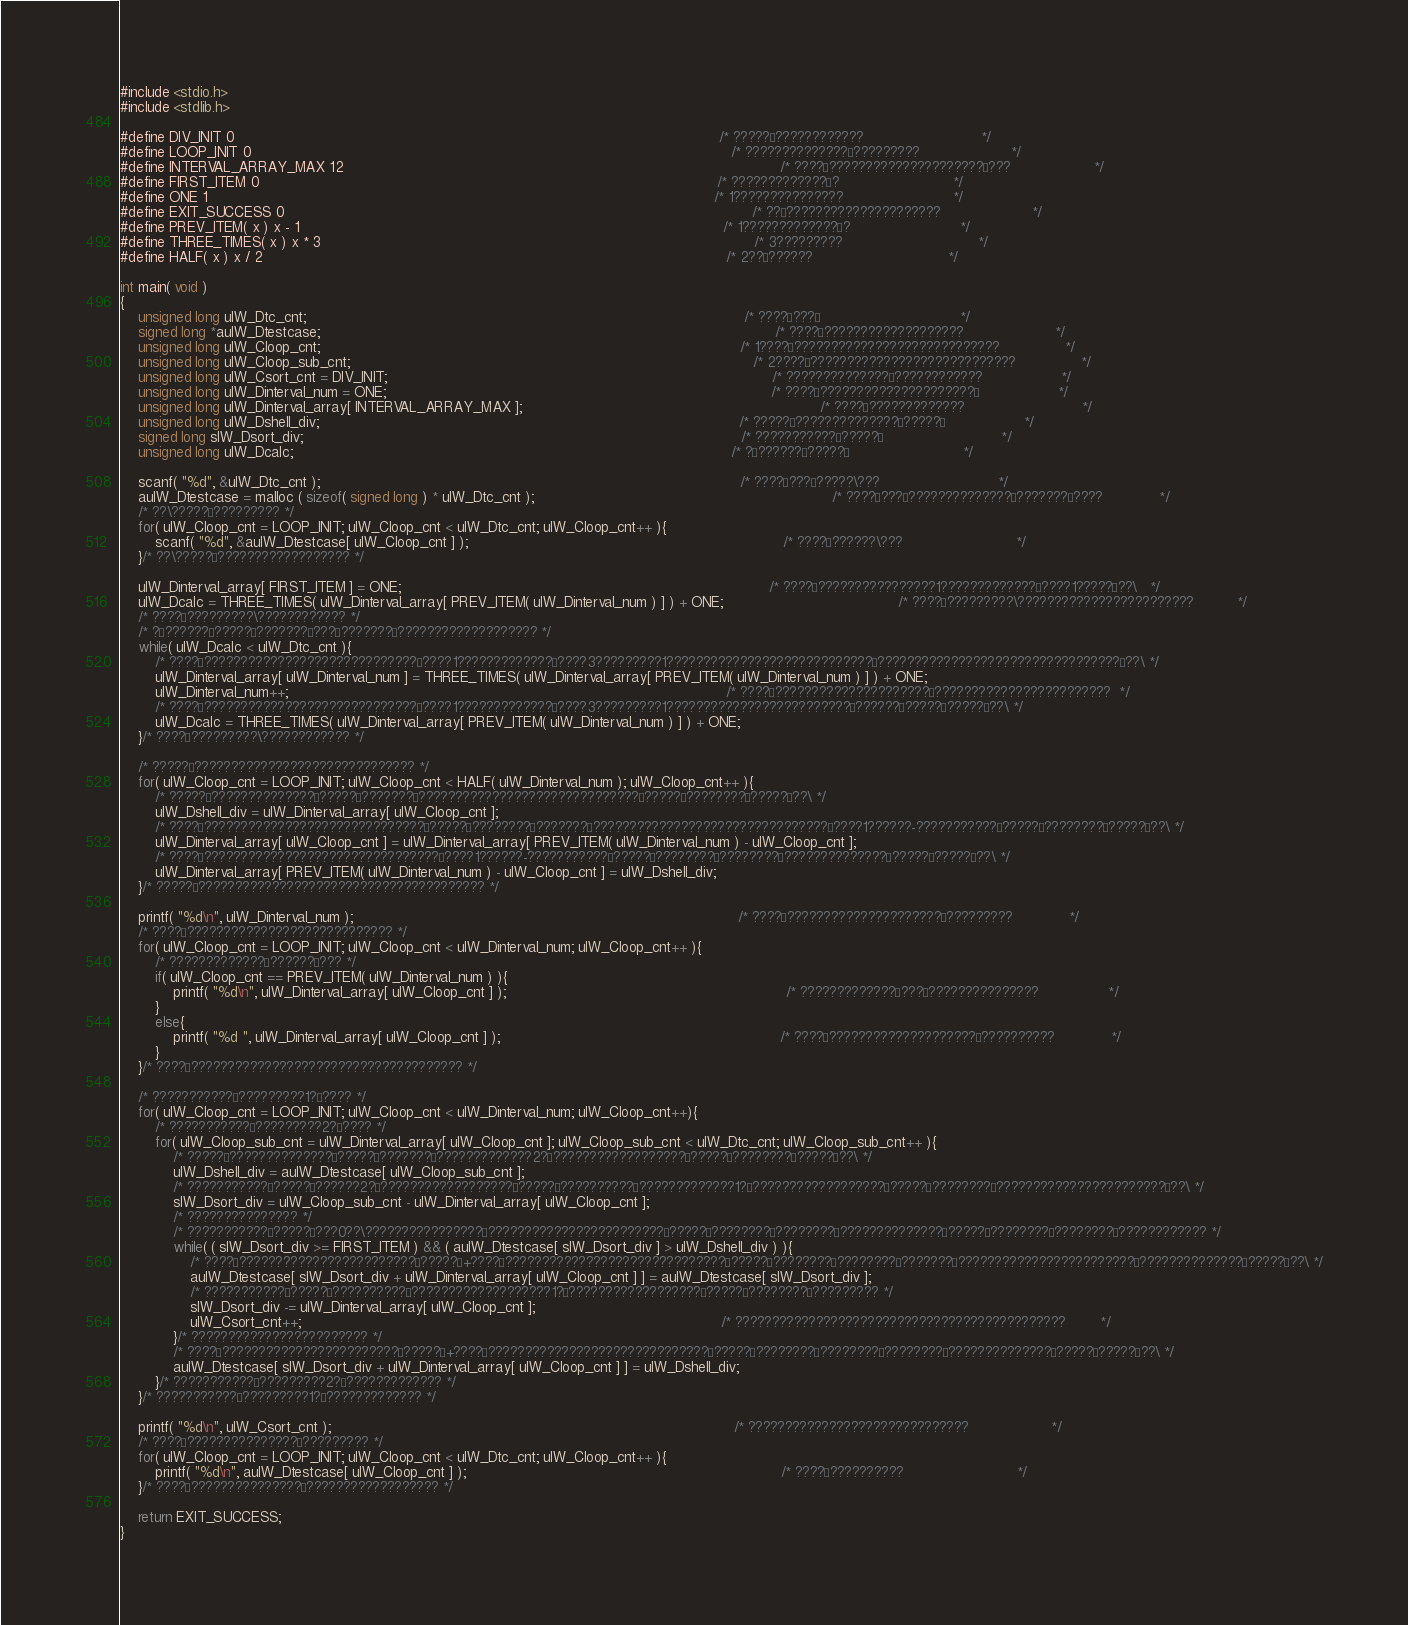Convert code to text. <code><loc_0><loc_0><loc_500><loc_500><_C_>#include <stdio.h>
#include <stdlib.h>

#define DIV_INIT 0																												/* ?????°????????????							*/
#define LOOP_INIT 0																												/* ??????????????°?????????						*/
#define INTERVAL_ARRAY_MAX 12																									/* ????´?????????????????????§???					*/
#define FIRST_ITEM 0																											/* ?????????????´?							*/
#define ONE 1																													/* 1???????????????							*/
#define EXIT_SUCCESS 0																											/* ??£?????????????????????						*/
#define PREV_ITEM( x ) x - 1																									/* 1?????????????´?							*/
#define THREE_TIMES( x ) x * 3																									/* 3?????????								*/
#define HALF( x ) x / 2																											/* 2??§??????								*/

int main( void )
{
	unsigned long ulW_Dtc_cnt;																									/* ????´???°								*/
	signed long *aulW_Dtestcase;																										/* ????´???????????????????						*/
	unsigned long ulW_Cloop_cnt;																								/* 1????±????????????????????????????				*/
	unsigned long ulW_Cloop_sub_cnt;																							/* 2????±????????????????????????????				*/
	unsigned long ulW_Csort_cnt = DIV_INIT;																						/* ??????????????°????????????					*/
	unsigned long ulW_Dinterval_num = ONE;																						/* ????´?????????????????????°					*/
	unsigned long ulW_Dinterval_array[ INTERVAL_ARRAY_MAX ];																	/* ????´?????????????							*/
	unsigned long ulW_Dshell_div;																								/* ?????§??????????????¨?????°					*/
	signed long slW_Dsort_div;																									/* ???????????¨?????°							*/
	unsigned long ulW_Dcalc;																									/* ?¨??????¨?????°							*/

	scanf( "%d", &ulW_Dtc_cnt );																								/* ????´???°?????\???							*/
	aulW_Dtestcase = malloc ( sizeof( signed long ) * ulW_Dtc_cnt );																	/* ????´???°??????????????¢???????¢????				*/
	/* ??\?????¨????????? */
	for( ulW_Cloop_cnt = LOOP_INIT; ulW_Cloop_cnt < ulW_Dtc_cnt; ulW_Cloop_cnt++ ){
		scanf( "%d", &aulW_Dtestcase[ ulW_Cloop_cnt ] );																		/* ????´??????\???							*/
	}/* ??\?????¨?????????????????? */

	ulW_Dinterval_array[ FIRST_ITEM ] = ONE;																					/* ????´????????????????1?????????????´????1?????£??\	*/
	ulW_Dcalc = THREE_TIMES( ulW_Dinterval_array[ PREV_ITEM( ulW_Dinterval_num ) ] ) + ONE;										/* ????´?????????\????????????????????????			*/
	/* ????´?????????\???????????? */
	/* ?¨??????¨?????°???????´???°???????°??????????????????? */
	while( ulW_Dcalc < ulW_Dtc_cnt ){
		/* ????´?????????????????????????????´????1?????????????´????3?????????1????????????????????????????´?????????????????????????????????£??\ */
		ulW_Dinterval_array[ ulW_Dinterval_num ] = THREE_TIMES( ulW_Dinterval_array[ PREV_ITEM( ulW_Dinterval_num ) ] ) + ONE;
		ulW_Dinterval_num++;																									/* ????´?????????????????????°????????????????????????	*/
		/* ????´?????????????????????????????´????1?????????????´????3?????????1?????????????????????????¨??????¨?????°?????£??\ */
		ulW_Dcalc = THREE_TIMES( ulW_Dinterval_array[ PREV_ITEM( ulW_Dinterval_num ) ] ) + ONE;
	}/* ????´?????????\???????????? */

	/* ?????§?????????????????????????????? */
	for( ulW_Cloop_cnt = LOOP_INIT; ulW_Cloop_cnt < HALF( ulW_Dinterval_num ); ulW_Cloop_cnt++ ){
		/* ?????§??????????????¨?????°???????´??????????????????????????????¨?????°????????°?????£??\ */
		ulW_Dshell_div = ulW_Dinterval_array[ ulW_Cloop_cnt ];
		/* ????´??????????????????????????????¨?????°????????°???????´????????????????????????????????´????1??????-???????????¨?????°????????°?????£??\ */
		ulW_Dinterval_array[ ulW_Cloop_cnt ] = ulW_Dinterval_array[ PREV_ITEM( ulW_Dinterval_num ) - ulW_Cloop_cnt ];
		/* ????´????????????????????????????????´????1??????-???????????¨?????°????????°????????§??????????????¨?????°?????£??\ */
		ulW_Dinterval_array[ PREV_ITEM( ulW_Dinterval_num ) - ulW_Cloop_cnt ] = ulW_Dshell_div;
	}/* ?????§??????????????????????????????????????? */

	printf( "%d\n", ulW_Dinterval_num );																						/* ????´?????????????????????°?????????				*/
	/* ????´???????????????????????????? */
	for( ulW_Cloop_cnt = LOOP_INIT; ulW_Cloop_cnt < ulW_Dinterval_num; ulW_Cloop_cnt++ ){
		/* ?????????????´??????´??? */
		if( ulW_Cloop_cnt == PREV_ITEM( ulW_Dinterval_num ) ){
			printf( "%d\n", ulW_Dinterval_array[ ulW_Cloop_cnt ] );																/* ?????????????´???¨???????????????				*/
		}
		else{
			printf( "%d ", ulW_Dinterval_array[ ulW_Cloop_cnt ] );																/* ????´????????????????????´??????????				*/
		}
	}/* ????´????????????????????????????????????? */

	/* ???????????¨?????????1?±???? */
	for( ulW_Cloop_cnt = LOOP_INIT; ulW_Cloop_cnt < ulW_Dinterval_num; ulW_Cloop_cnt++){
		/* ???????????¨?????????2?±???? */
		for( ulW_Cloop_sub_cnt = ulW_Dinterval_array[ ulW_Cloop_cnt ]; ulW_Cloop_sub_cnt < ulW_Dtc_cnt; ulW_Cloop_sub_cnt++ ){
			/* ?????§??????????????¨?????°???????´?????????????2?±??????????????????¨?????°????????°?????£??\ */
			ulW_Dshell_div = aulW_Dtestcase[ ulW_Cloop_sub_cnt ];
			/* ???????????¨?????°??????2?±??????????????????¨?????°??????????´?????????????1?±??????????????????¨?????°????????°???????????????????????£??\ */
			slW_Dsort_div = ulW_Cloop_sub_cnt - ulW_Dinterval_array[ ulW_Cloop_cnt ];
			/* ??????????????? */
			/* ???????????¨?????°???0??\????????????????´????????????????????????¨?????°????????°????????§??????????????¨?????°????????§????????´???????????? */
			while( ( slW_Dsort_div >= FIRST_ITEM ) && ( aulW_Dtestcase[ slW_Dsort_div ] > ulW_Dshell_div ) ){
				/* ????´????????????????????????¨?????°+????´??????????????????????????????¨?????°????????°????????°???????´????????????????????????¨??????????????°?????£??\ */
				aulW_Dtestcase[ slW_Dsort_div + ulW_Dinterval_array[ ulW_Cloop_cnt ] ] = aulW_Dtestcase[ slW_Dsort_div ];
				/* ???????????¨?????°??????????´???????????????????1?±??????????????????¨?????°????????°????????? */
				slW_Dsort_div -= ulW_Dinterval_array[ ulW_Cloop_cnt ];
				ulW_Csort_cnt++;																								/* ?????????????????????????????????????????????		*/
			}/* ???????????????????????? */
			/* ????´????????????????????????¨?????°+????´??????????????????????????????¨?????°????????°????????°????????§??????????????¨?????°?????£??\ */
			aulW_Dtestcase[ slW_Dsort_div + ulW_Dinterval_array[ ulW_Cloop_cnt ] ] = ulW_Dshell_div;
		}/* ???????????¨?????????2?±????????????? */
	}/* ???????????¨?????????1?±????????????? */

	printf( "%d\n", ulW_Csort_cnt );																							/* ??????????????????????????????					*/
	/* ????´???????????????¨????????? */
	for( ulW_Cloop_cnt = LOOP_INIT; ulW_Cloop_cnt < ulW_Dtc_cnt; ulW_Cloop_cnt++ ){
		printf( "%d\n", aulW_Dtestcase[ ulW_Cloop_cnt ] );																		/* ????´??????????							*/
	}/* ????´???????????????¨?????????????????? */

	return EXIT_SUCCESS;
}</code> 